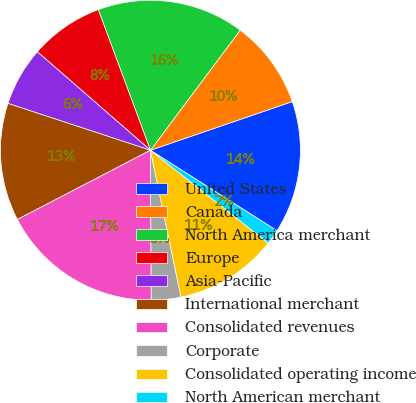Convert chart. <chart><loc_0><loc_0><loc_500><loc_500><pie_chart><fcel>United States<fcel>Canada<fcel>North America merchant<fcel>Europe<fcel>Asia-Pacific<fcel>International merchant<fcel>Consolidated revenues<fcel>Corporate<fcel>Consolidated operating income<fcel>North American merchant<nl><fcel>14.28%<fcel>9.52%<fcel>15.87%<fcel>7.94%<fcel>6.35%<fcel>12.69%<fcel>17.45%<fcel>3.18%<fcel>11.11%<fcel>1.6%<nl></chart> 